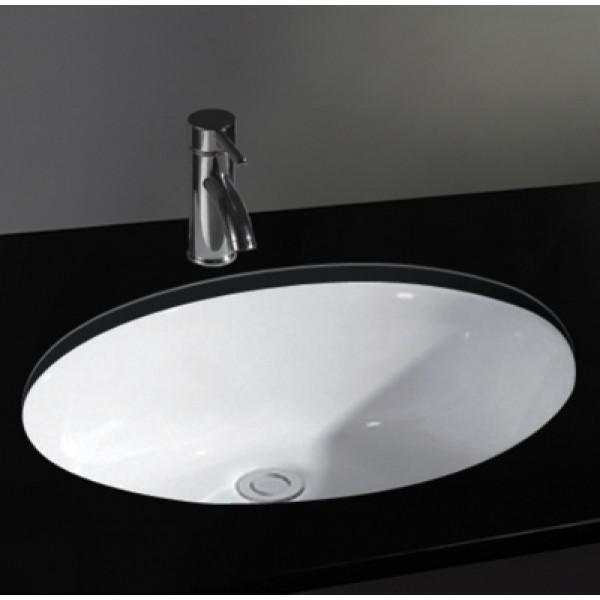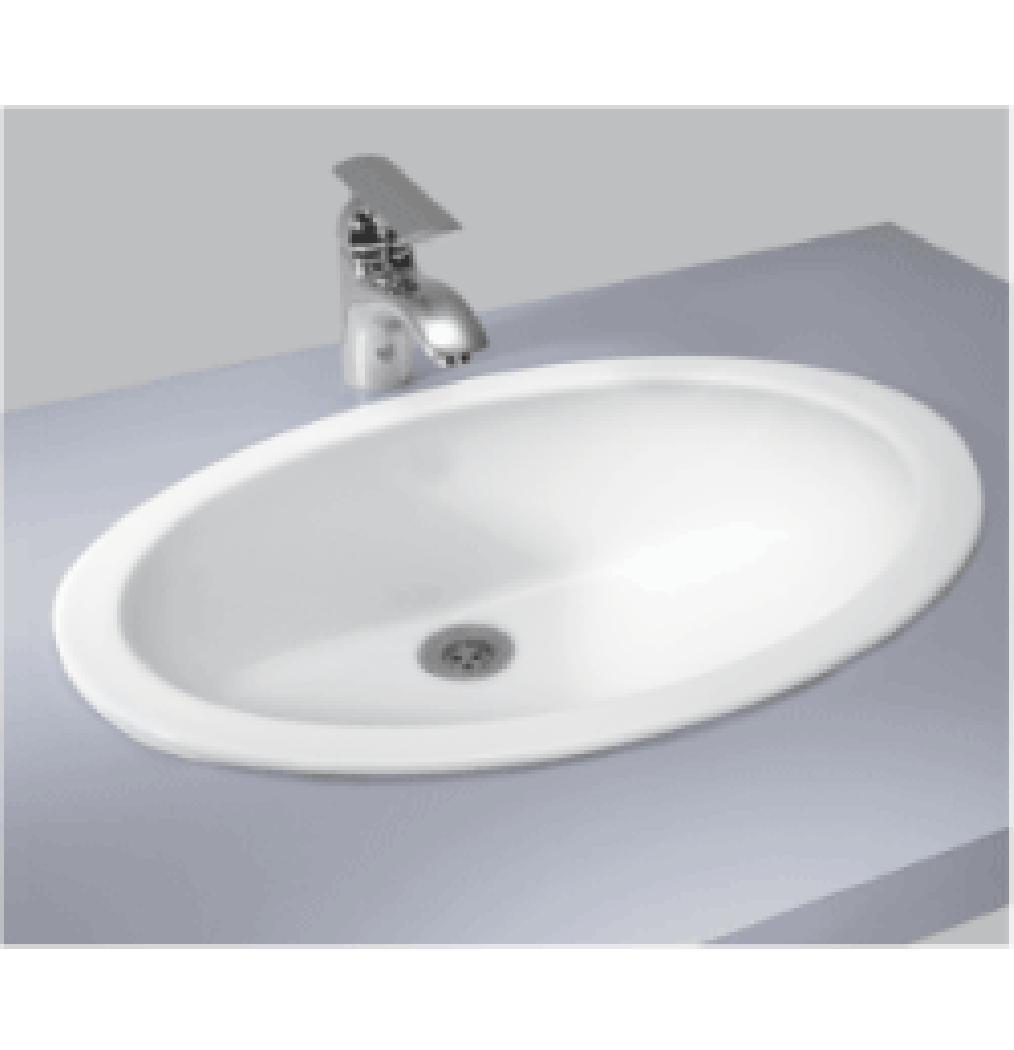The first image is the image on the left, the second image is the image on the right. Considering the images on both sides, is "There are two sinks with black countertops." valid? Answer yes or no. No. 